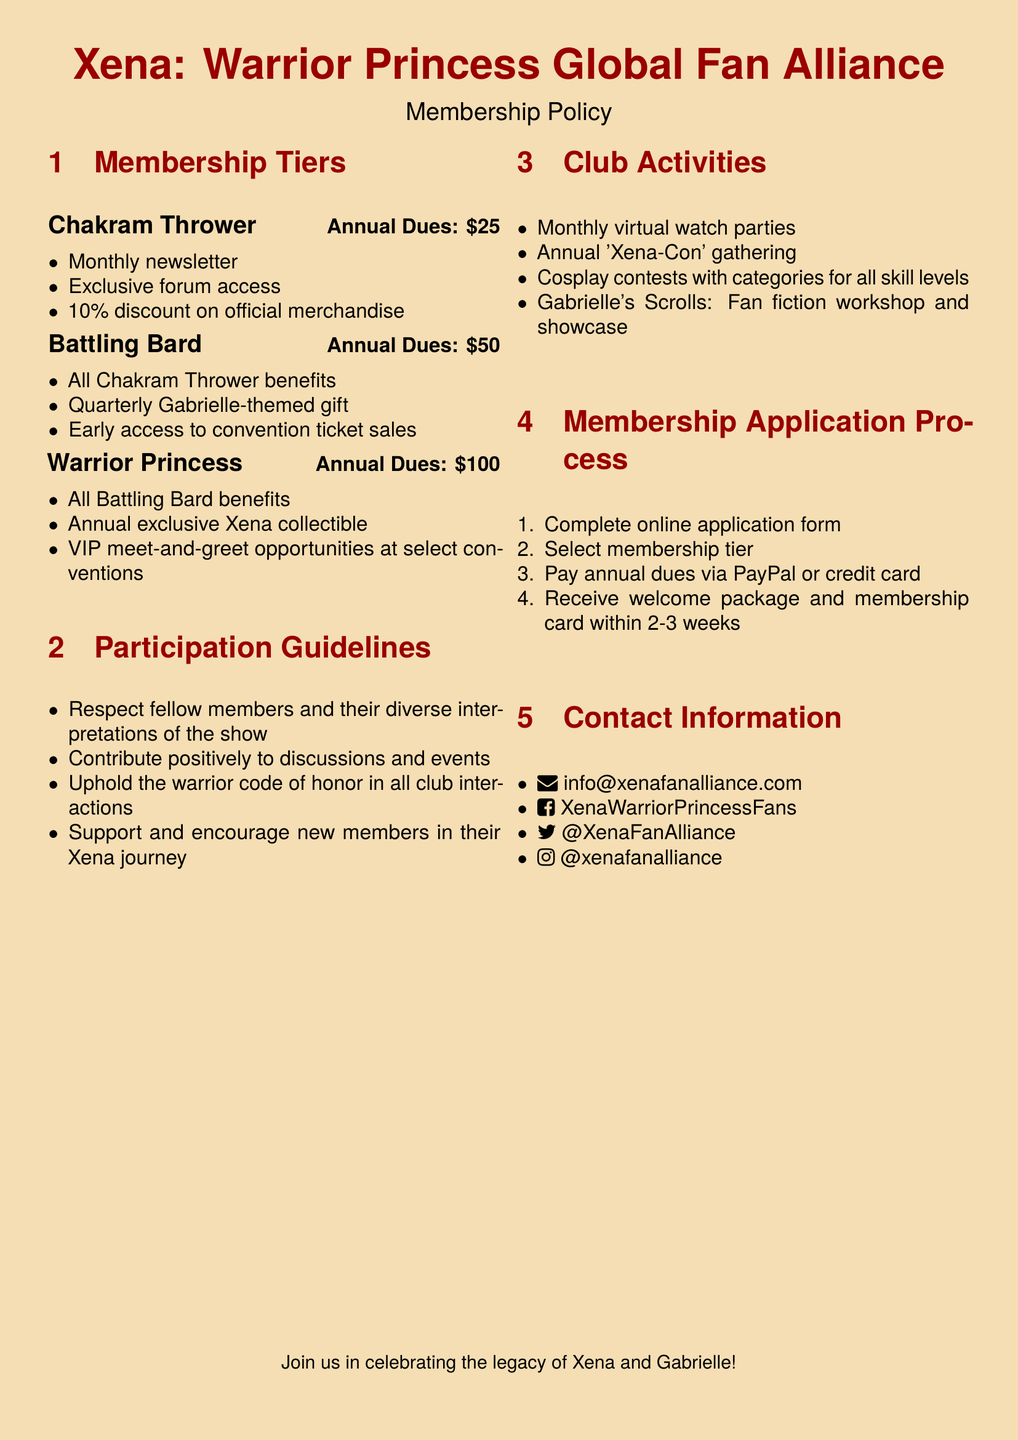What are the annual dues for the Chakram Thrower tier? The annual dues for the Chakram Thrower tier are stated in the membership tiers section.
Answer: 25 What benefits do Battling Bard members receive? The benefits for Battling Bard members are listed under the Battling Bard tier in the membership section.
Answer: All Chakram Thrower benefits, Quarterly Gabrielle-themed gift, Early access to convention ticket sales What is one of the club activities mentioned? The document lists several club activities in the club activities section, from which one can be selected.
Answer: Monthly virtual watch parties How many weeks does it take to receive the welcome package? The document specifies the time frame for receiving the welcome package in the membership application process section.
Answer: 2-3 weeks What is one guideline members must follow? The participation guidelines section outlines several rules that members must follow, from which any guideline can be selected.
Answer: Respect fellow members and their diverse interpretations of the show What exclusive item does the Warrior Princess tier include? The Warrior Princess tier details unique benefits, specifically highlighting what exclusive item is included.
Answer: Annual exclusive Xena collectible How do members pay their annual dues? The payment methods for annual dues are described in the membership application process section.
Answer: PayPal or credit card What is the title of the gathering organized by the club? The club activities section mentions various events, including a specific gathering with a title.
Answer: Xena-Con 